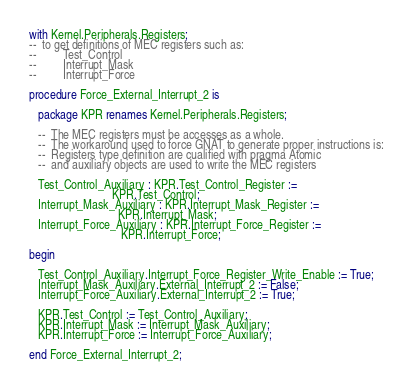<code> <loc_0><loc_0><loc_500><loc_500><_Ada_>with Kernel.Peripherals.Registers;
--  to get definitions of MEC registers such as:
--         Test_Control
--         Interrupt_Mask
--         Interrupt_Force

procedure Force_External_Interrupt_2 is

   package KPR renames Kernel.Peripherals.Registers;

   --  The MEC registers must be accesses as a whole.
   --  The workaround used to force GNAT to generate proper instructions is:
   --  Registers type definition are cualified with pragma Atomic
   --  and auxiliary objects are used to write the MEC registers

   Test_Control_Auxiliary : KPR.Test_Control_Register :=
                            KPR.Test_Control;
   Interrupt_Mask_Auxiliary : KPR.Interrupt_Mask_Register :=
                              KPR.Interrupt_Mask;
   Interrupt_Force_Auxiliary : KPR.Interrupt_Force_Register :=
                               KPR.Interrupt_Force;

begin

   Test_Control_Auxiliary.Interrupt_Force_Register_Write_Enable := True;
   Interrupt_Mask_Auxiliary.External_Interrupt_2 := False;
   Interrupt_Force_Auxiliary.External_Interrupt_2 := True;

   KPR.Test_Control := Test_Control_Auxiliary;
   KPR.Interrupt_Mask := Interrupt_Mask_Auxiliary;
   KPR.Interrupt_Force := Interrupt_Force_Auxiliary;

end Force_External_Interrupt_2;
</code> 